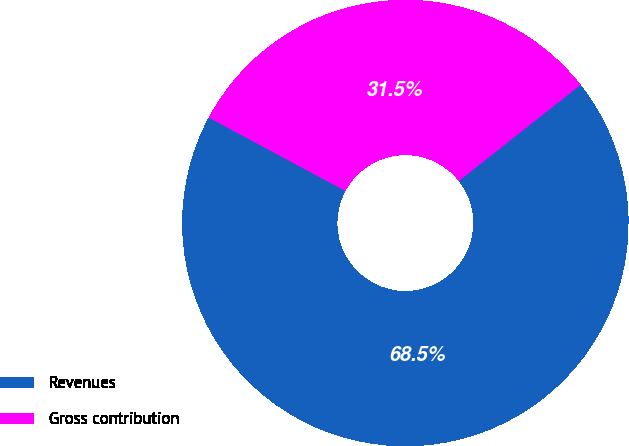Convert chart. <chart><loc_0><loc_0><loc_500><loc_500><pie_chart><fcel>Revenues<fcel>Gross contribution<nl><fcel>68.47%<fcel>31.53%<nl></chart> 